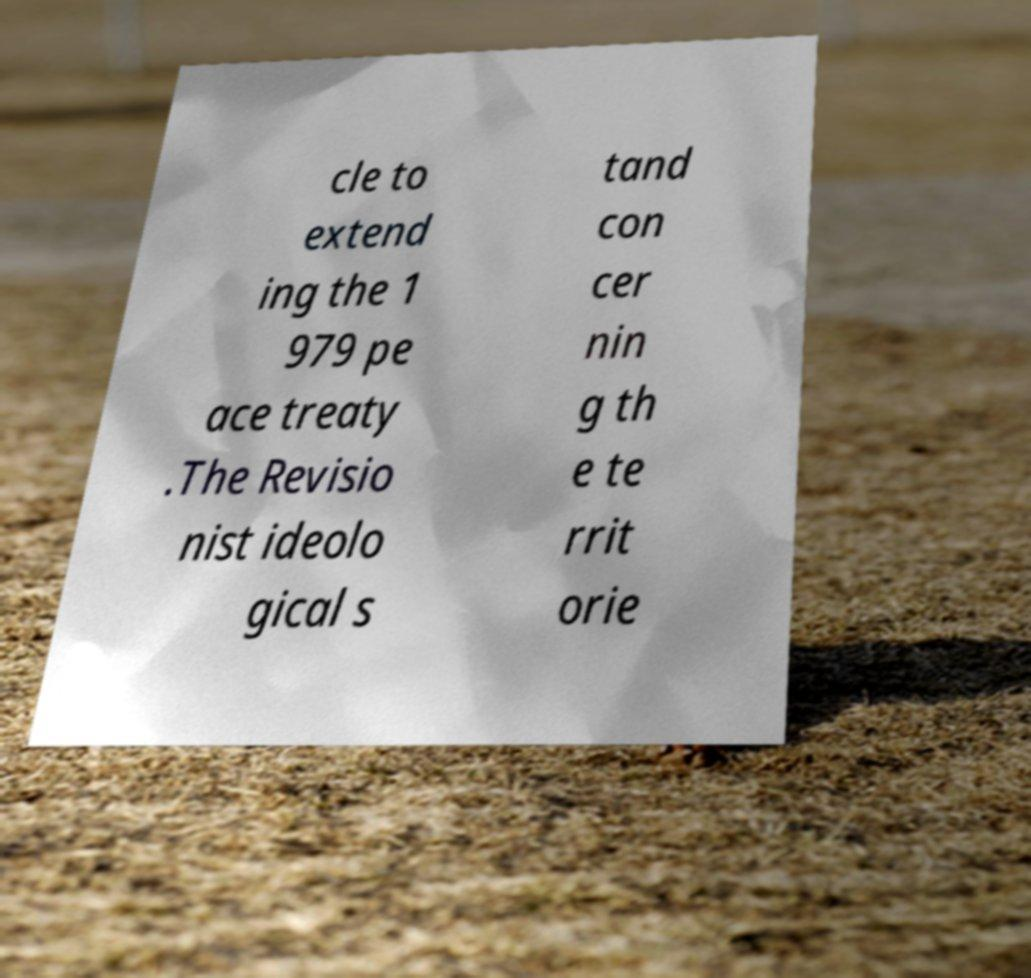Please identify and transcribe the text found in this image. cle to extend ing the 1 979 pe ace treaty .The Revisio nist ideolo gical s tand con cer nin g th e te rrit orie 